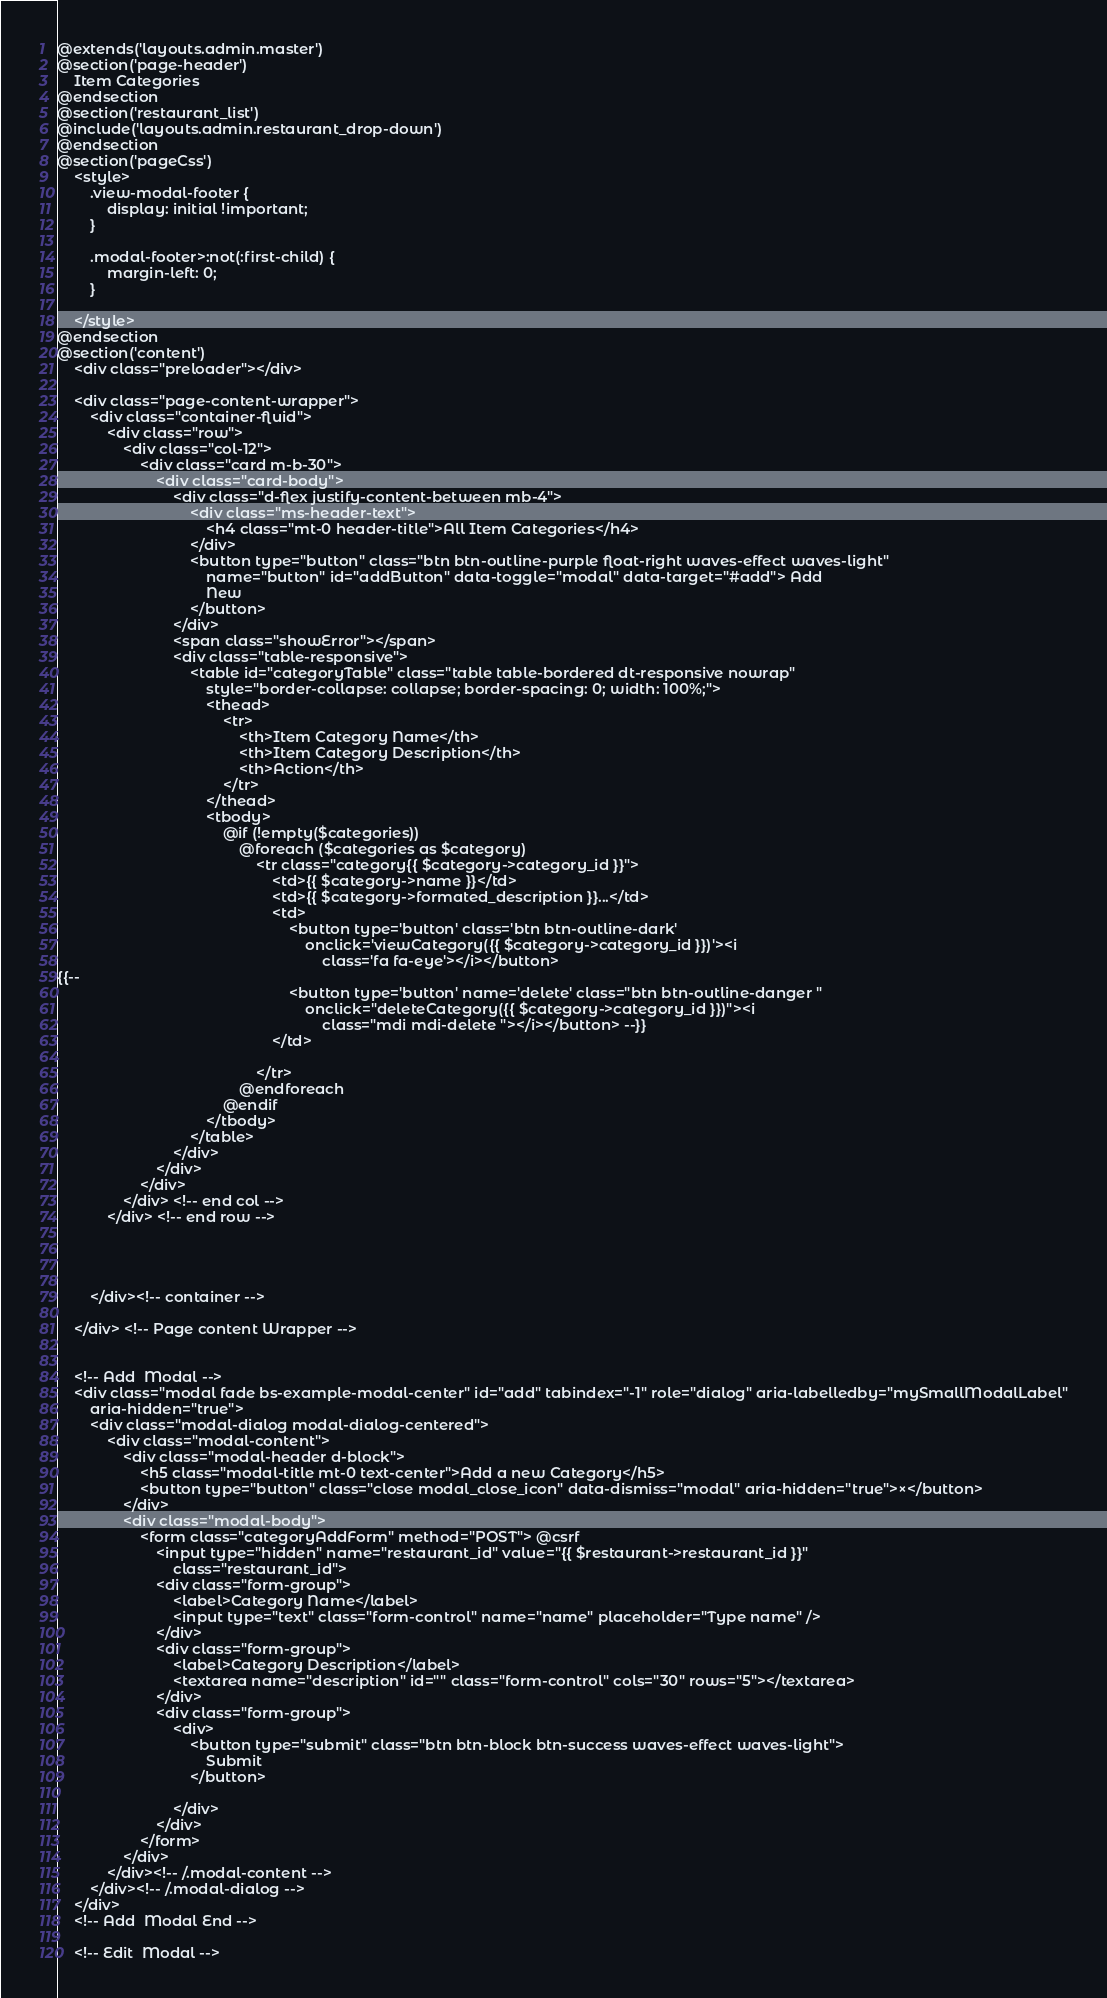<code> <loc_0><loc_0><loc_500><loc_500><_PHP_>@extends('layouts.admin.master')
@section('page-header')
    Item Categories
@endsection
@section('restaurant_list')
@include('layouts.admin.restaurant_drop-down')
@endsection
@section('pageCss')
    <style>
        .view-modal-footer {
            display: initial !important;
        }

        .modal-footer>:not(:first-child) {
            margin-left: 0;
        }

    </style>
@endsection
@section('content')
    <div class="preloader"></div>

    <div class="page-content-wrapper">
        <div class="container-fluid">
            <div class="row">
                <div class="col-12">
                    <div class="card m-b-30">
                        <div class="card-body">
                            <div class="d-flex justify-content-between mb-4">
                                <div class="ms-header-text">
                                    <h4 class="mt-0 header-title">All Item Categories</h4>
                                </div>
                                <button type="button" class="btn btn-outline-purple float-right waves-effect waves-light"
                                    name="button" id="addButton" data-toggle="modal" data-target="#add"> Add
                                    New
                                </button>
                            </div>
                            <span class="showError"></span>
                            <div class="table-responsive">
                                <table id="categoryTable" class="table table-bordered dt-responsive nowrap"
                                    style="border-collapse: collapse; border-spacing: 0; width: 100%;">
                                    <thead>
                                        <tr>
                                            <th>Item Category Name</th>
                                            <th>Item Category Description</th>
                                            <th>Action</th>
                                        </tr>
                                    </thead>
                                    <tbody>
                                        @if (!empty($categories))
                                            @foreach ($categories as $category)
                                                <tr class="category{{ $category->category_id }}">
                                                    <td>{{ $category->name }}</td>
                                                    <td>{{ $category->formated_description }}...</td>
                                                    <td>
                                                        <button type='button' class='btn btn-outline-dark'
                                                            onclick='viewCategory({{ $category->category_id }})'><i
                                                                class='fa fa-eye'></i></button>
{{-- 
                                                        <button type='button' name='delete' class="btn btn-outline-danger "
                                                            onclick="deleteCategory({{ $category->category_id }})"><i
                                                                class="mdi mdi-delete "></i></button> --}}
                                                    </td>

                                                </tr>
                                            @endforeach
                                        @endif
                                    </tbody>
                                </table>
                            </div>
                        </div>
                    </div>
                </div> <!-- end col -->
            </div> <!-- end row -->




        </div><!-- container -->

    </div> <!-- Page content Wrapper -->


    <!-- Add  Modal -->
    <div class="modal fade bs-example-modal-center" id="add" tabindex="-1" role="dialog" aria-labelledby="mySmallModalLabel"
        aria-hidden="true">
        <div class="modal-dialog modal-dialog-centered">
            <div class="modal-content">
                <div class="modal-header d-block">
                    <h5 class="modal-title mt-0 text-center">Add a new Category</h5>
                    <button type="button" class="close modal_close_icon" data-dismiss="modal" aria-hidden="true">×</button>
                </div>
                <div class="modal-body">
                    <form class="categoryAddForm" method="POST"> @csrf
                        <input type="hidden" name="restaurant_id" value="{{ $restaurant->restaurant_id }}"
                            class="restaurant_id">
                        <div class="form-group">
                            <label>Category Name</label>
                            <input type="text" class="form-control" name="name" placeholder="Type name" />
                        </div>
                        <div class="form-group">
                            <label>Category Description</label>
                            <textarea name="description" id="" class="form-control" cols="30" rows="5"></textarea>
                        </div>
                        <div class="form-group">
                            <div>
                                <button type="submit" class="btn btn-block btn-success waves-effect waves-light">
                                    Submit
                                </button>

                            </div>
                        </div>
                    </form>
                </div>
            </div><!-- /.modal-content -->
        </div><!-- /.modal-dialog -->
    </div>
    <!-- Add  Modal End -->

    <!-- Edit  Modal --></code> 